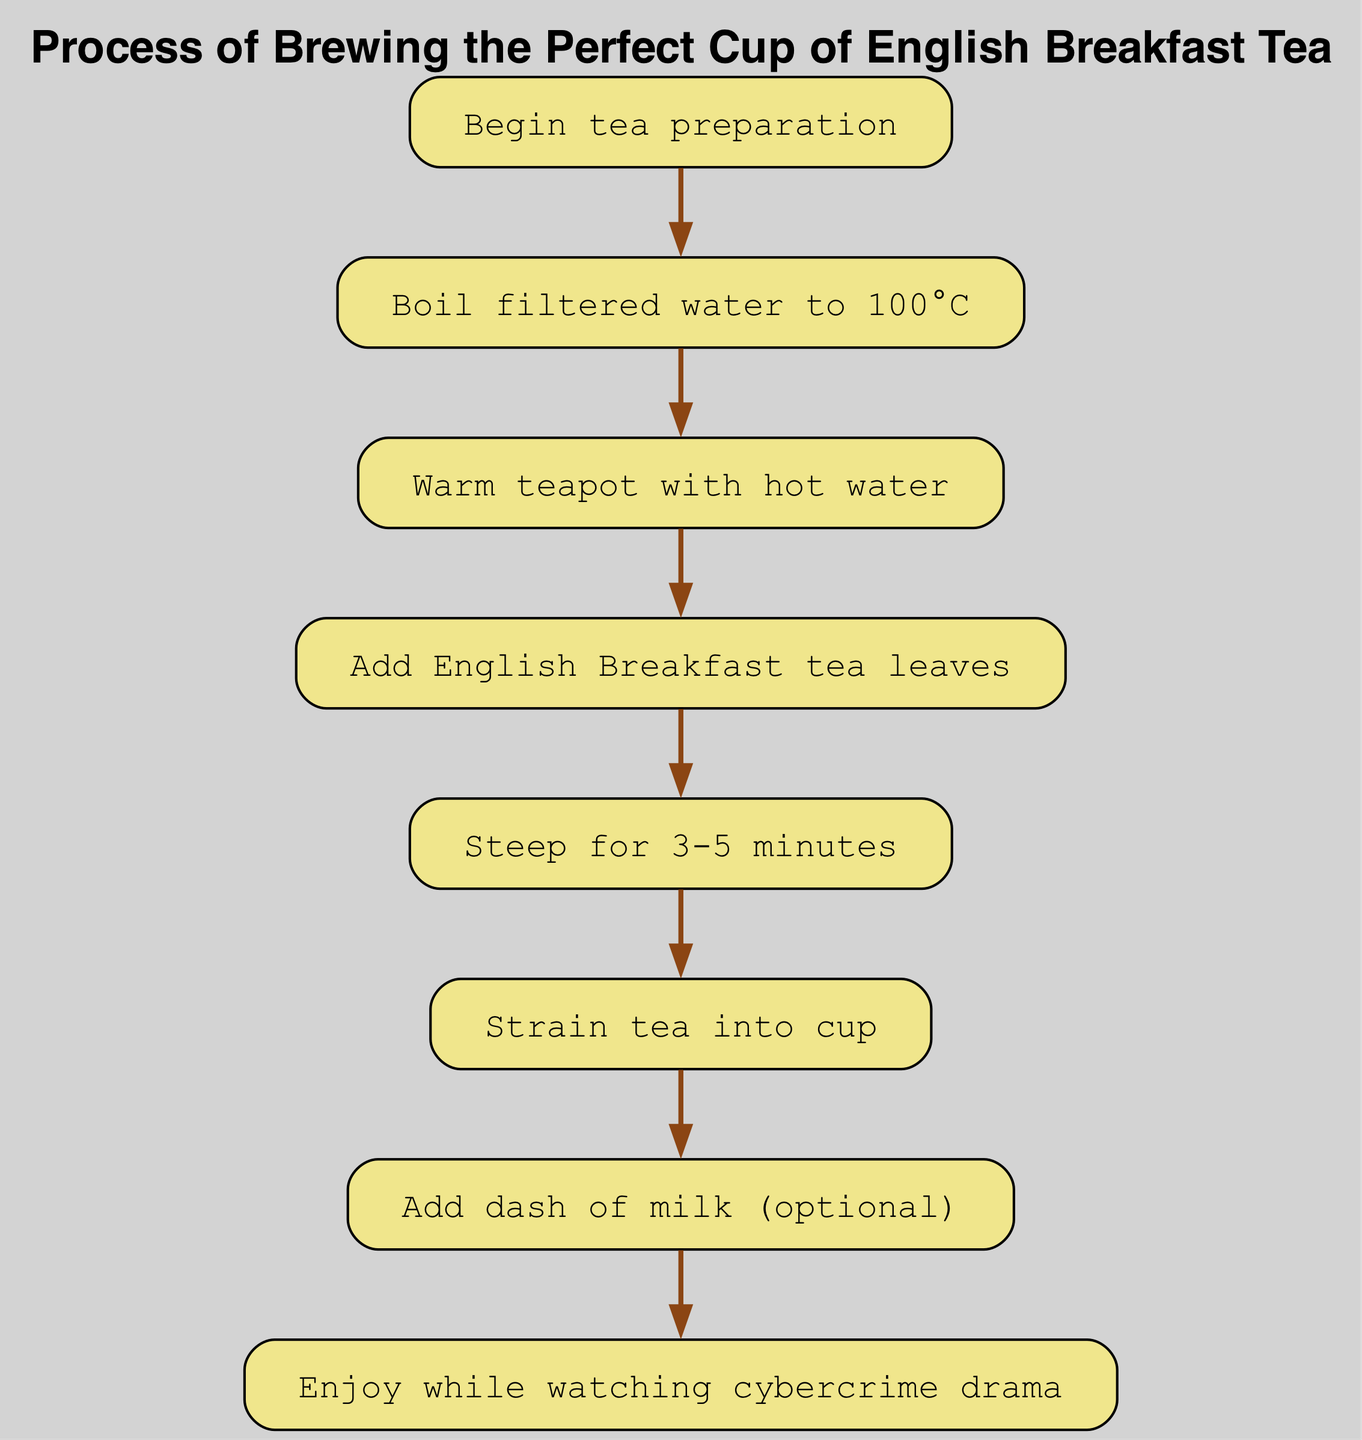What is the first step in the process? The first step is identified in the diagram as "Begin tea preparation," which is the starting node in the flow chart.
Answer: Begin tea preparation How many nodes are there in the diagram? By counting the distinct steps listed in the nodes section of the diagram, there are a total of eight nodes.
Answer: 8 What is the last action before enjoying the tea? According to the flow of the diagram, the action taken just before enjoying the tea is "Add dash of milk (optional)," which directly precedes the enjoyment step.
Answer: Add dash of milk (optional) Which step comes after boiling the water? Following the "Boil filtered water to 100°C," the next step indicated in the sequence is "Warm teapot with hot water." This shows the order of operations visually.
Answer: Warm teapot with hot water How many edges connect the nodes? The edges represent the connections between nodes. Counting these connections in the edges section gives a total of seven edges.
Answer: 7 What step is required to prepare the tea for steeping? The preparation for steeping the tea follows adding the English Breakfast tea leaves, ensuring that it is ready for the next step. Thus, the step is "Add English Breakfast tea leaves."
Answer: Add English Breakfast tea leaves What is the duration recommended for steeping the tea? The diagram specifies that the tea should be steeped for a duration of "3-5 minutes," indicating the optimal time frame for flavor extraction.
Answer: 3-5 minutes What optional ingredient can you add before enjoying the tea? The diagram indicates that a "dash of milk" is an optional addition that can be included just before the final enjoyment of the tea.
Answer: Dash of milk 